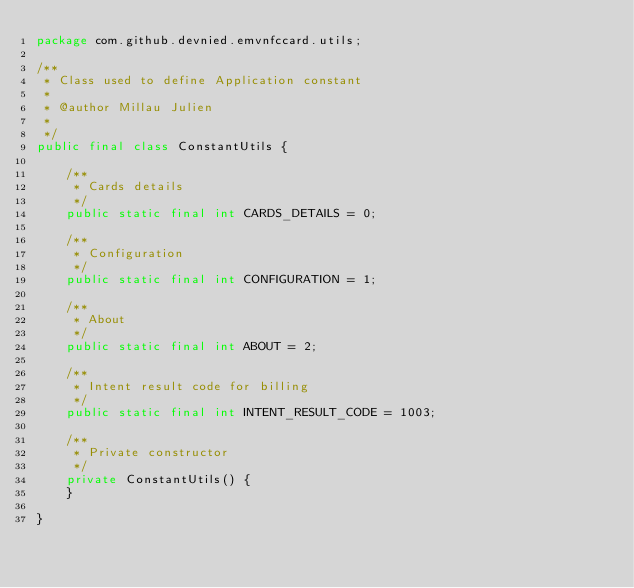<code> <loc_0><loc_0><loc_500><loc_500><_Java_>package com.github.devnied.emvnfccard.utils;

/**
 * Class used to define Application constant
 * 
 * @author Millau Julien
 * 
 */
public final class ConstantUtils {

	/**
	 * Cards details
	 */
	public static final int CARDS_DETAILS = 0;

	/**
	 * Configuration
	 */
	public static final int CONFIGURATION = 1;

	/**
	 * About
	 */
	public static final int ABOUT = 2;

	/**
	 * Intent result code for billing
	 */
	public static final int INTENT_RESULT_CODE = 1003;

	/**
	 * Private constructor
	 */
	private ConstantUtils() {
	}

}
</code> 